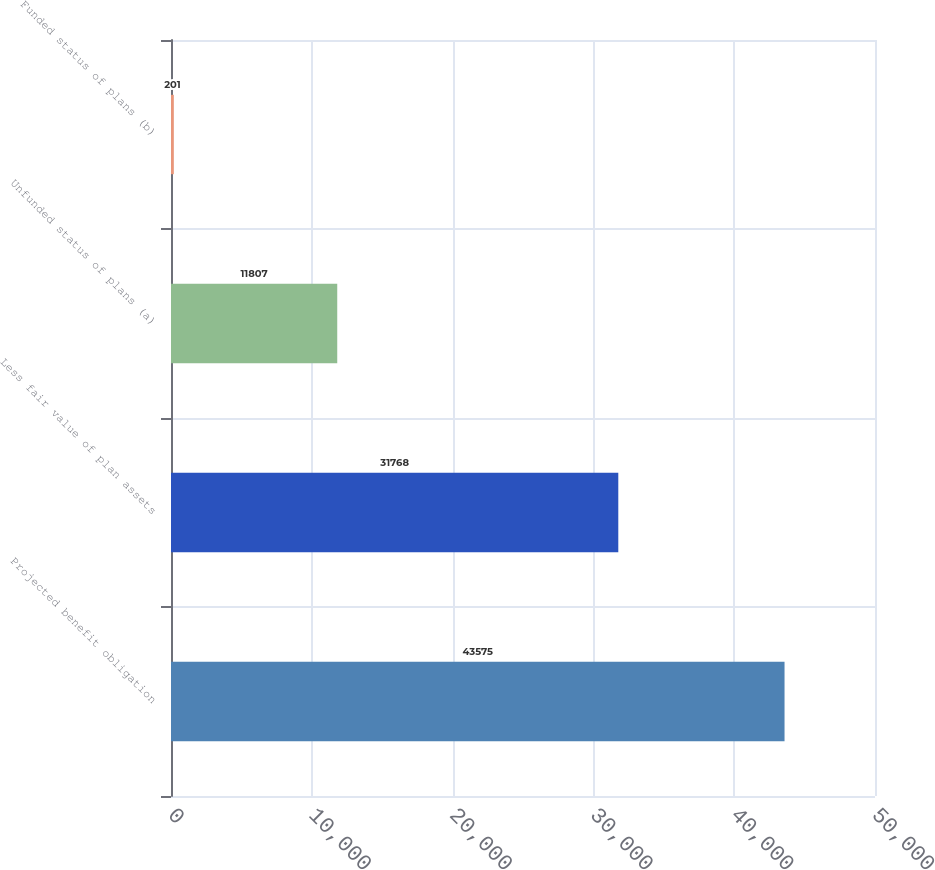<chart> <loc_0><loc_0><loc_500><loc_500><bar_chart><fcel>Projected benefit obligation<fcel>Less fair value of plan assets<fcel>Unfunded status of plans (a)<fcel>Funded status of plans (b)<nl><fcel>43575<fcel>31768<fcel>11807<fcel>201<nl></chart> 